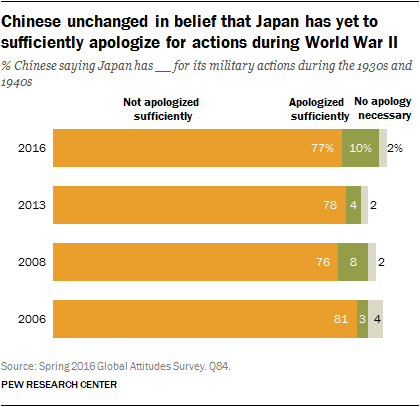What does this graph indicate about the opinions of Chinese citizens over time regarding Japan's apologies for actions during World War II? The graph shows that the opinion of Chinese citizens has remained relatively consistent from 2006 to 2016, with the majority believing that Japan has not apologized sufficiently for its military actions during the 1930s and 1940s. There's a slight decrease in this sentiment over time, but it remains the prevailing view. 